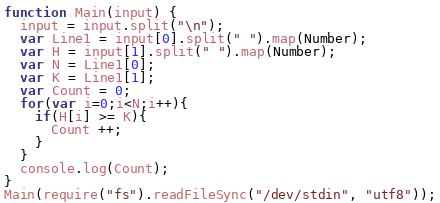Convert code to text. <code><loc_0><loc_0><loc_500><loc_500><_JavaScript_>function Main(input) {
  input = input.split("\n");
  var Line1 = input[0].split(" ").map(Number);
  var H = input[1].split(" ").map(Number);
  var N = Line1[0];
  var K = Line1[1];
  var Count = 0;
  for(var i=0;i<N;i++){
    if(H[i] >= K){
      Count ++;
    }
  }
  console.log(Count);
}
Main(require("fs").readFileSync("/dev/stdin", "utf8"));
</code> 